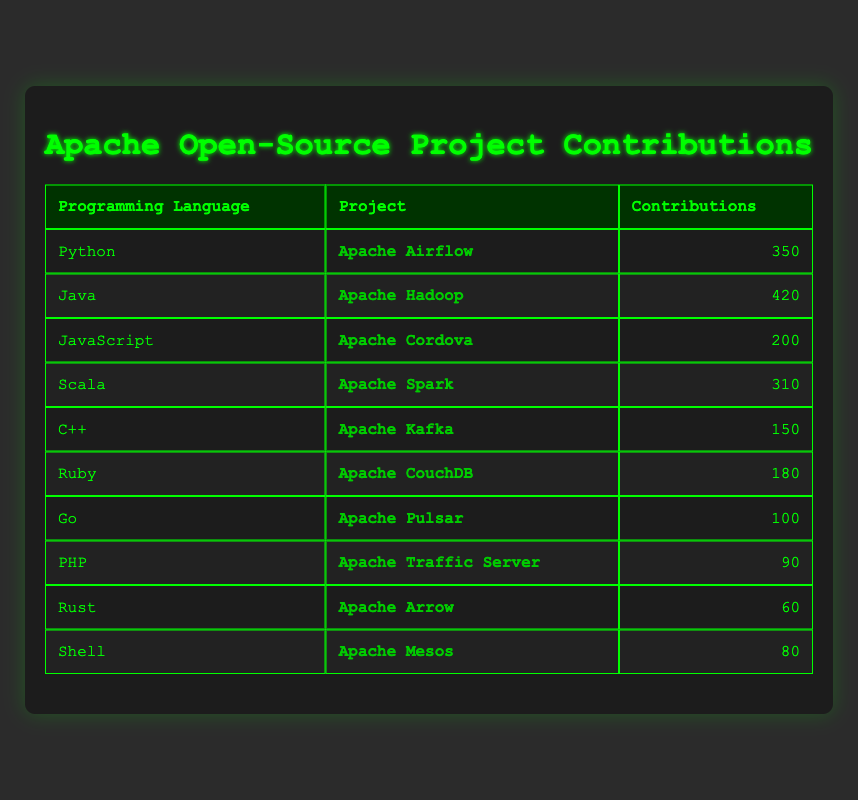What is the project with the highest contributions? By looking at the "Contributions" column, I identify the highest value, which is 420. Referring to the "Project" column associated with it, the project is "Apache Hadoop."
Answer: Apache Hadoop How many contributions does Apache Pulsar have? The "Contributions" column for "Apache Pulsar" shows the value of 100.
Answer: 100 Which programming language has the least contributions? I review the "Contributions" column and find the minimum value, which is 60 for "Rust," indicating it has the least contributions.
Answer: Rust What is the total number of contributions for all projects combined? I add the contributions from all projects: (350 + 420 + 200 + 310 + 150 + 180 + 100 + 90 + 60 + 80) = 2040.
Answer: 2040 Is there a project that uses Ruby? Yes, I check the "Programming Language" column for Ruby and find "Apache CouchDB" listed under it.
Answer: Yes What is the average number of contributions across all projects? To find the average, I sum all contributions which is 2040, then divide it by the number of projects (10). 2040 / 10 = 204.
Answer: 204 Which two programming languages have contributions greater than 200? I review the contributions to find languages with values greater than 200, which are Python (350), Java (420), and Scala (310). There are three specific languages.
Answer: Python and Java (among others) How many contributions does Java have compared to Go? Java has 420 contributions, and Go has 100 contributions. I subtract Go's contributions from Java's to have 420 - 100 = 320.
Answer: 320 What percentage of total contributions does Apache Airflow represent? Apache Airflow has 350 contributions, so I calculate the percentage from the total (2040). This is (350/2040) * 100, resulting in about 17.16%.
Answer: 17.16% 